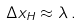Convert formula to latex. <formula><loc_0><loc_0><loc_500><loc_500>\Delta x _ { H } \approx \lambda \, .</formula> 